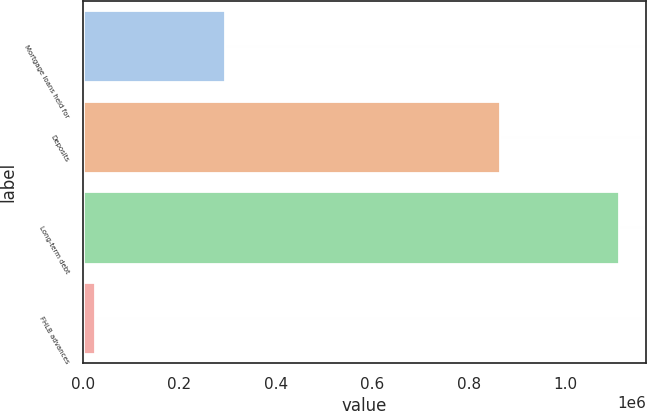<chart> <loc_0><loc_0><loc_500><loc_500><bar_chart><fcel>Mortgage loans held for<fcel>Deposits<fcel>Long-term debt<fcel>FHLB advances<nl><fcel>295154<fcel>865318<fcel>1.11289e+06<fcel>24998<nl></chart> 